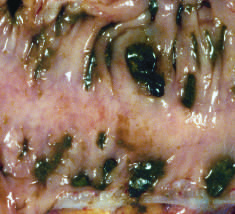does gram show regularly spaced stool-filled diverticulae?
Answer the question using a single word or phrase. No 